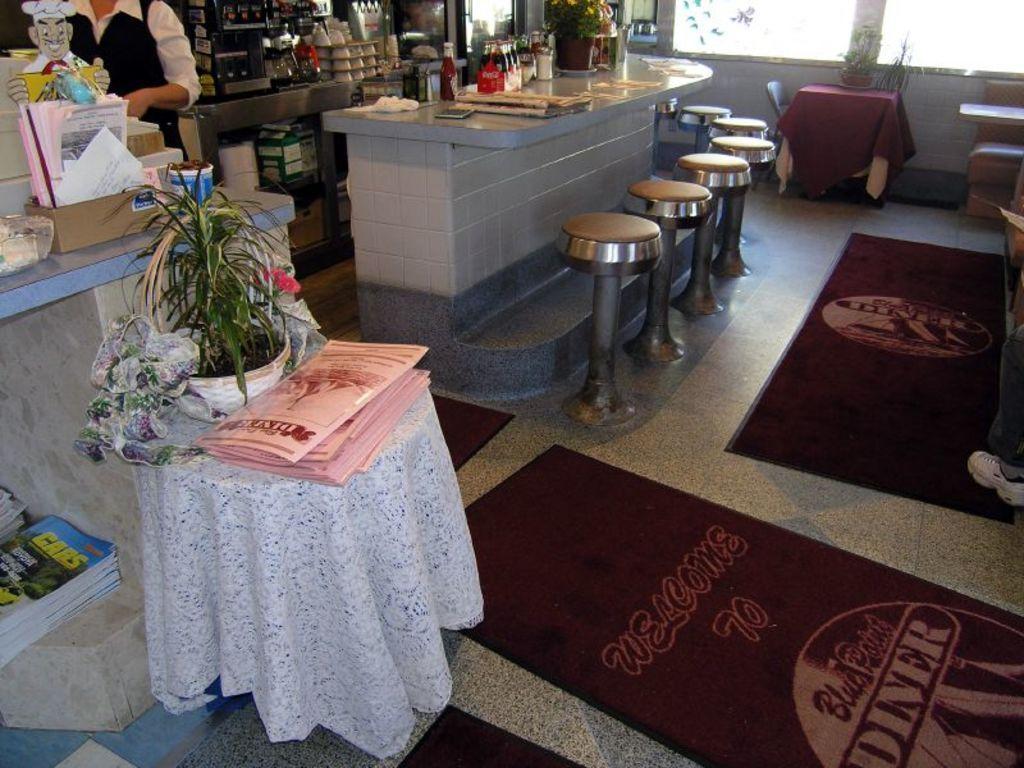How would you summarize this image in a sentence or two? In this image I see a person over here and I also see there are counter tops and few things on it and there are lot of stools, table, a chair and few plants. 